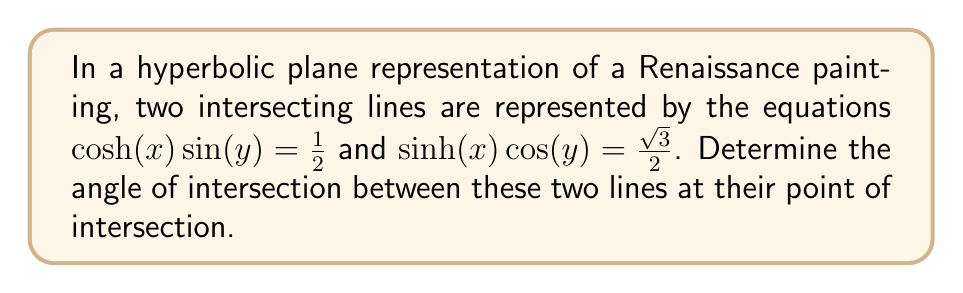Can you answer this question? To find the angle between two intersecting lines on a hyperbolic plane, we'll follow these steps:

1. Find the point of intersection:
   Solve the system of equations:
   $$\cosh(x) \sin(y) = \frac{1}{2}$$
   $$\sinh(x) \cos(y) = \frac{\sqrt{3}}{2}$$
   
   The solution is $x = \ln(2)$ and $y = \frac{\pi}{6}$.

2. Calculate the partial derivatives of each equation with respect to x and y:
   For the first equation: $f(x,y) = \cosh(x) \sin(y) - \frac{1}{2}$
   $$\frac{\partial f}{\partial x} = \sinh(x) \sin(y)$$
   $$\frac{\partial f}{\partial y} = \cosh(x) \cos(y)$$
   
   For the second equation: $g(x,y) = \sinh(x) \cos(y) - \frac{\sqrt{3}}{2}$
   $$\frac{\partial g}{\partial x} = \cosh(x) \cos(y)$$
   $$\frac{\partial g}{\partial y} = -\sinh(x) \sin(y)$$

3. Evaluate these partial derivatives at the point of intersection:
   $$\frac{\partial f}{\partial x} = \sinh(\ln(2)) \sin(\frac{\pi}{6}) = \frac{\sqrt{3}}{4}$$
   $$\frac{\partial f}{\partial y} = \cosh(\ln(2)) \cos(\frac{\pi}{6}) = \frac{3\sqrt{3}}{4}$$
   $$\frac{\partial g}{\partial x} = \cosh(\ln(2)) \cos(\frac{\pi}{6}) = \frac{3\sqrt{3}}{4}$$
   $$\frac{\partial g}{\partial y} = -\sinh(\ln(2)) \sin(\frac{\pi}{6}) = -\frac{\sqrt{3}}{4}$$

4. The angle θ between the lines is given by the formula:
   $$\cos(\theta) = \frac{|\frac{\partial f}{\partial x}\frac{\partial g}{\partial x} + \frac{\partial f}{\partial y}\frac{\partial g}{\partial y}|}{\sqrt{(\frac{\partial f}{\partial x})^2 + (\frac{\partial f}{\partial y})^2}\sqrt{(\frac{\partial g}{\partial x})^2 + (\frac{\partial g}{\partial y})^2}}$$

5. Substitute the values:
   $$\cos(\theta) = \frac{|\frac{\sqrt{3}}{4} \cdot \frac{3\sqrt{3}}{4} + \frac{3\sqrt{3}}{4} \cdot (-\frac{\sqrt{3}}{4})|}{\sqrt{(\frac{\sqrt{3}}{4})^2 + (\frac{3\sqrt{3}}{4})^2}\sqrt{(\frac{3\sqrt{3}}{4})^2 + (-\frac{\sqrt{3}}{4})^2}}$$

6. Simplify:
   $$\cos(\theta) = \frac{0}{\sqrt{\frac{3}{16} + \frac{27}{16}} \cdot \sqrt{\frac{27}{16} + \frac{3}{16}}} = \frac{0}{\frac{15}{4}} = 0$$

7. Therefore, $\theta = \arccos(0) = \frac{\pi}{2}$
Answer: $\frac{\pi}{2}$ radians or 90° 